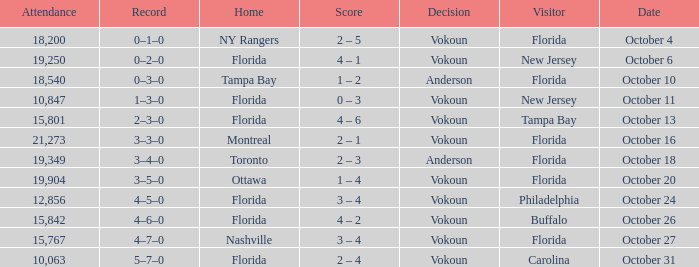Which team was home on October 13? Florida. 